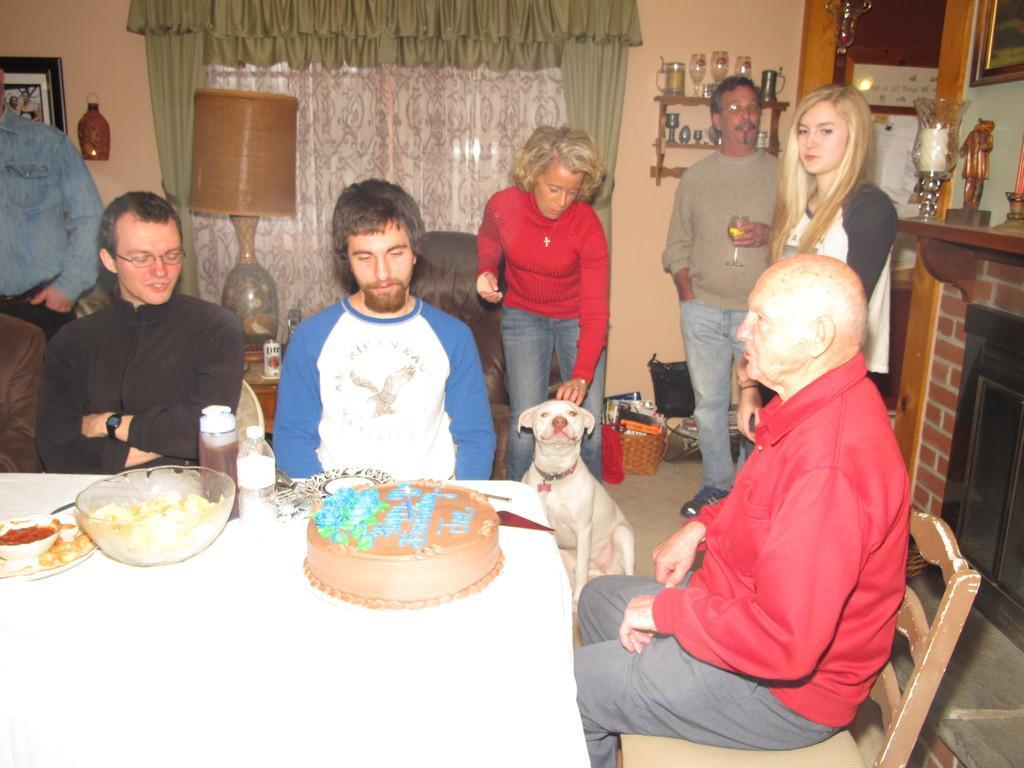Can you describe this image briefly? In the picture we can see this person wearing red color T-shirt, this person wearing white color T-shirt and this person wearing black color T-shirt are sitting on the chairs near the table where bowls in which food items are kept, we can see cake and bottles and few more things are placed on the table. In the background, we can see a few more people standing on the floor, we can see an dog, table lamp, photo frame on the wall, we can see some objects are placed on the shelf which is fixed to the wall, we can see curtains, fireplace and some showcase items. 